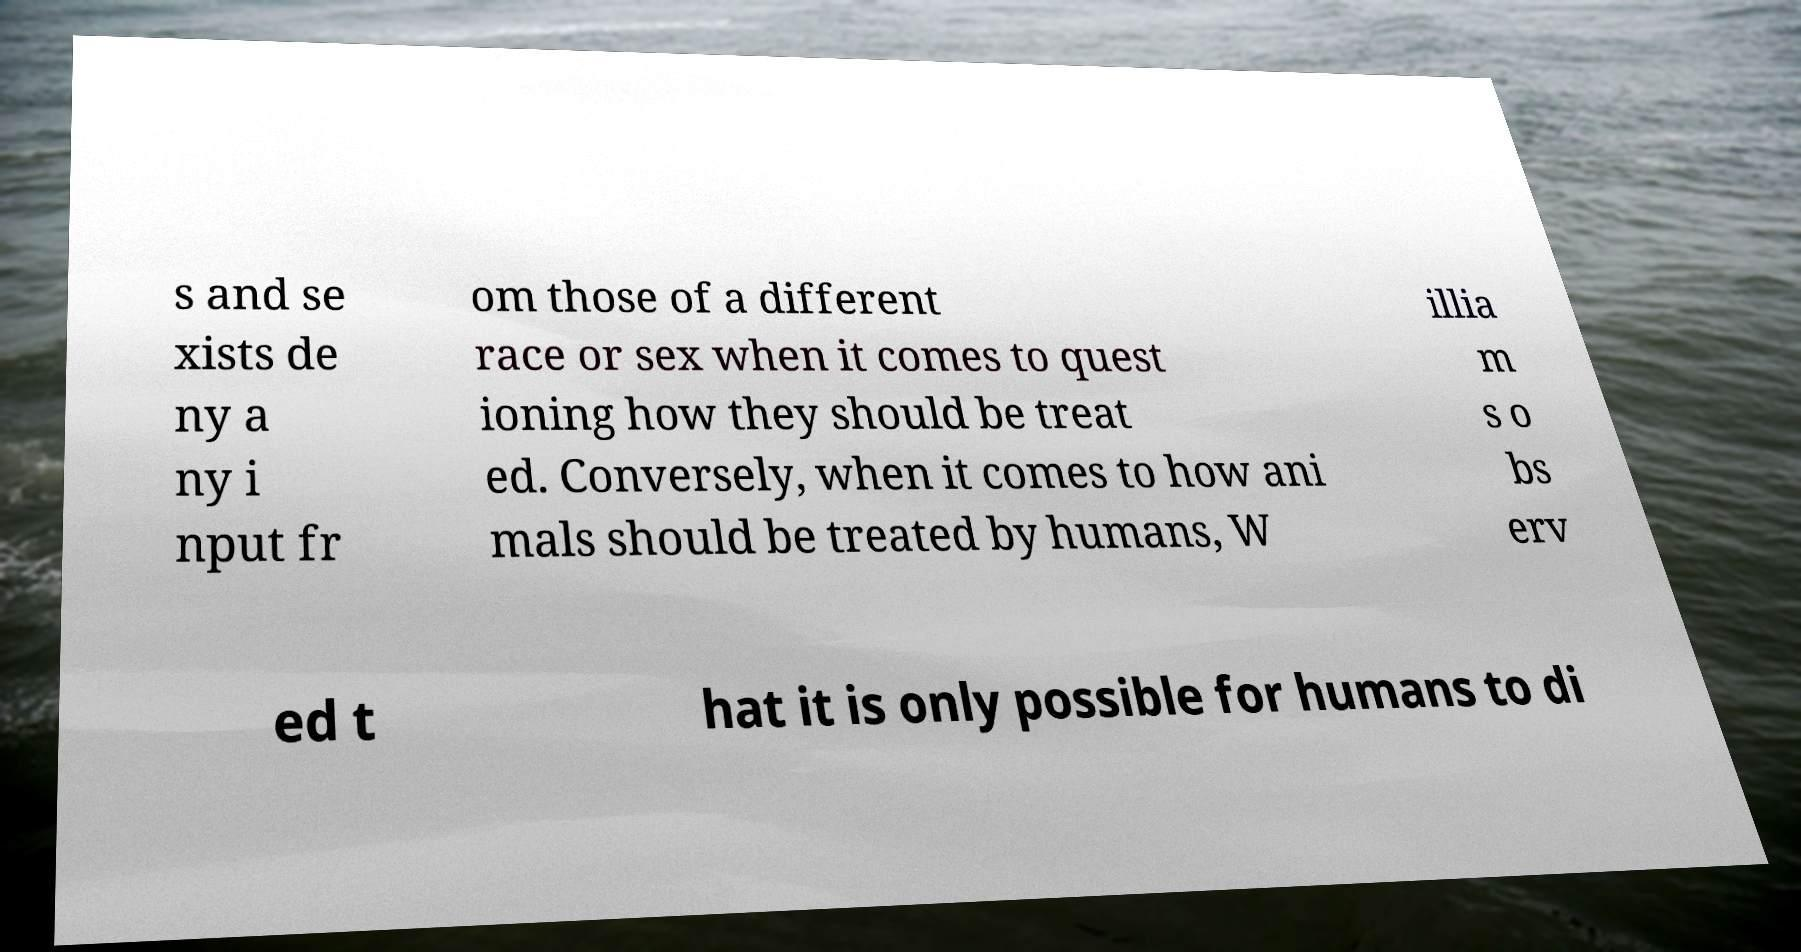Please read and relay the text visible in this image. What does it say? s and se xists de ny a ny i nput fr om those of a different race or sex when it comes to quest ioning how they should be treat ed. Conversely, when it comes to how ani mals should be treated by humans, W illia m s o bs erv ed t hat it is only possible for humans to di 